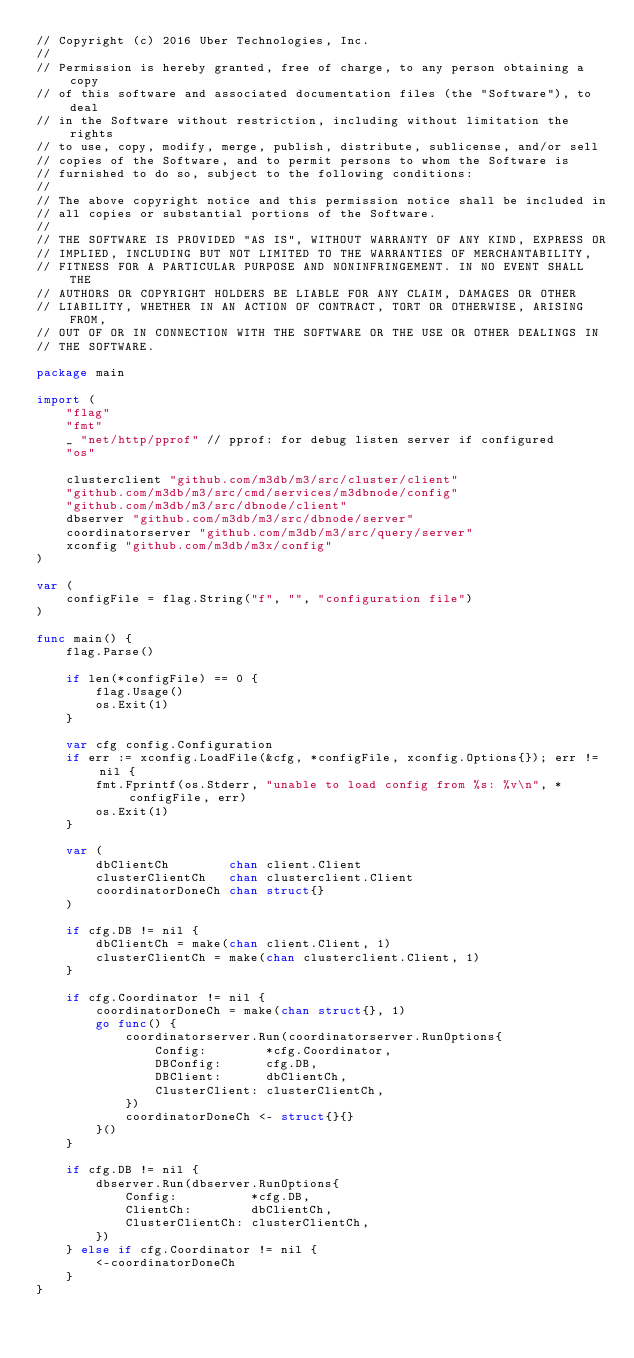<code> <loc_0><loc_0><loc_500><loc_500><_Go_>// Copyright (c) 2016 Uber Technologies, Inc.
//
// Permission is hereby granted, free of charge, to any person obtaining a copy
// of this software and associated documentation files (the "Software"), to deal
// in the Software without restriction, including without limitation the rights
// to use, copy, modify, merge, publish, distribute, sublicense, and/or sell
// copies of the Software, and to permit persons to whom the Software is
// furnished to do so, subject to the following conditions:
//
// The above copyright notice and this permission notice shall be included in
// all copies or substantial portions of the Software.
//
// THE SOFTWARE IS PROVIDED "AS IS", WITHOUT WARRANTY OF ANY KIND, EXPRESS OR
// IMPLIED, INCLUDING BUT NOT LIMITED TO THE WARRANTIES OF MERCHANTABILITY,
// FITNESS FOR A PARTICULAR PURPOSE AND NONINFRINGEMENT. IN NO EVENT SHALL THE
// AUTHORS OR COPYRIGHT HOLDERS BE LIABLE FOR ANY CLAIM, DAMAGES OR OTHER
// LIABILITY, WHETHER IN AN ACTION OF CONTRACT, TORT OR OTHERWISE, ARISING FROM,
// OUT OF OR IN CONNECTION WITH THE SOFTWARE OR THE USE OR OTHER DEALINGS IN
// THE SOFTWARE.

package main

import (
	"flag"
	"fmt"
	_ "net/http/pprof" // pprof: for debug listen server if configured
	"os"

	clusterclient "github.com/m3db/m3/src/cluster/client"
	"github.com/m3db/m3/src/cmd/services/m3dbnode/config"
	"github.com/m3db/m3/src/dbnode/client"
	dbserver "github.com/m3db/m3/src/dbnode/server"
	coordinatorserver "github.com/m3db/m3/src/query/server"
	xconfig "github.com/m3db/m3x/config"
)

var (
	configFile = flag.String("f", "", "configuration file")
)

func main() {
	flag.Parse()

	if len(*configFile) == 0 {
		flag.Usage()
		os.Exit(1)
	}

	var cfg config.Configuration
	if err := xconfig.LoadFile(&cfg, *configFile, xconfig.Options{}); err != nil {
		fmt.Fprintf(os.Stderr, "unable to load config from %s: %v\n", *configFile, err)
		os.Exit(1)
	}

	var (
		dbClientCh        chan client.Client
		clusterClientCh   chan clusterclient.Client
		coordinatorDoneCh chan struct{}
	)

	if cfg.DB != nil {
		dbClientCh = make(chan client.Client, 1)
		clusterClientCh = make(chan clusterclient.Client, 1)
	}

	if cfg.Coordinator != nil {
		coordinatorDoneCh = make(chan struct{}, 1)
		go func() {
			coordinatorserver.Run(coordinatorserver.RunOptions{
				Config:        *cfg.Coordinator,
				DBConfig:      cfg.DB,
				DBClient:      dbClientCh,
				ClusterClient: clusterClientCh,
			})
			coordinatorDoneCh <- struct{}{}
		}()
	}

	if cfg.DB != nil {
		dbserver.Run(dbserver.RunOptions{
			Config:          *cfg.DB,
			ClientCh:        dbClientCh,
			ClusterClientCh: clusterClientCh,
		})
	} else if cfg.Coordinator != nil {
		<-coordinatorDoneCh
	}
}
</code> 